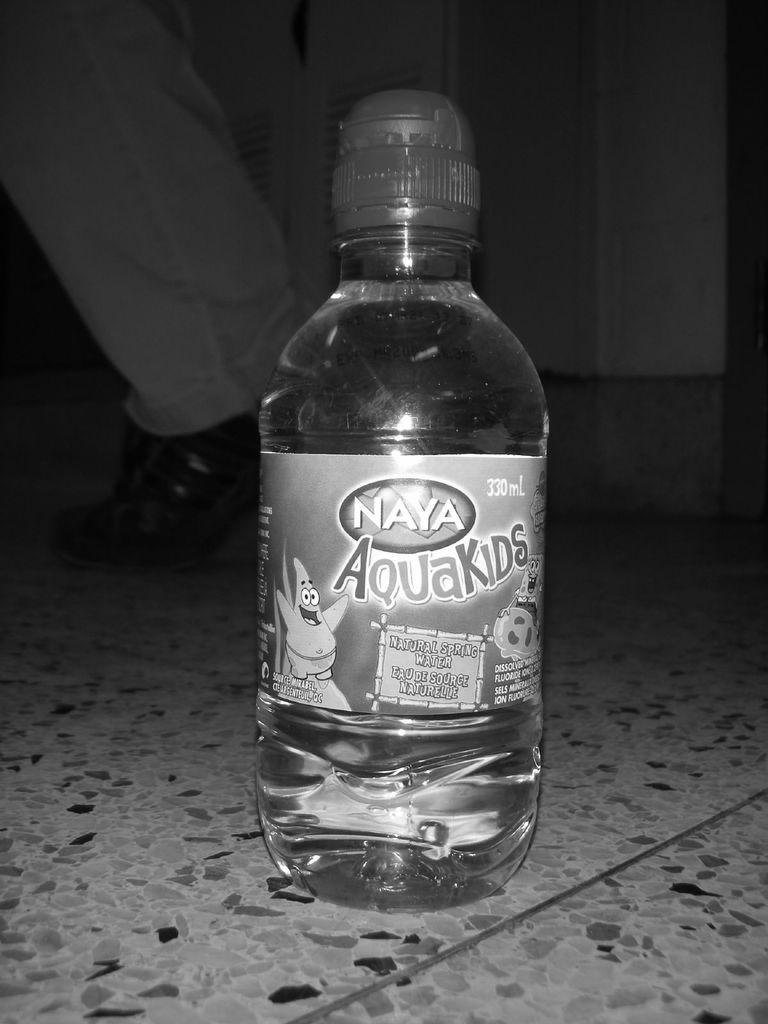What brand makes aquakids?
Keep it short and to the point. Naya. How many ml are in the bottle?
Your answer should be very brief. 330. 